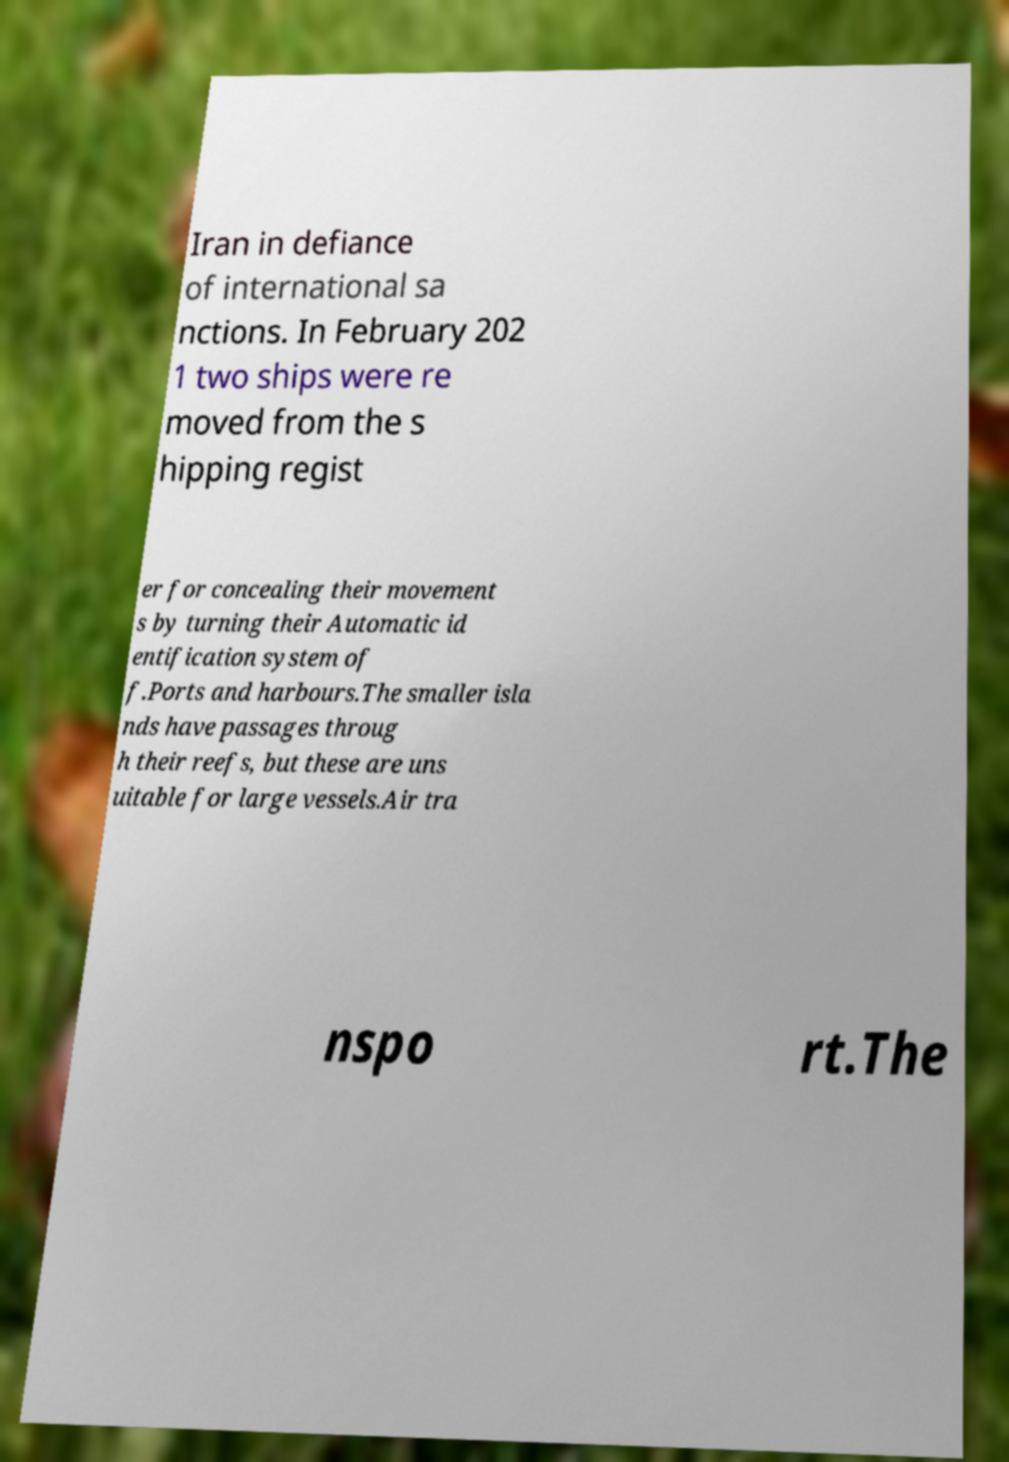For documentation purposes, I need the text within this image transcribed. Could you provide that? Iran in defiance of international sa nctions. In February 202 1 two ships were re moved from the s hipping regist er for concealing their movement s by turning their Automatic id entification system of f.Ports and harbours.The smaller isla nds have passages throug h their reefs, but these are uns uitable for large vessels.Air tra nspo rt.The 